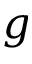Convert formula to latex. <formula><loc_0><loc_0><loc_500><loc_500>g</formula> 